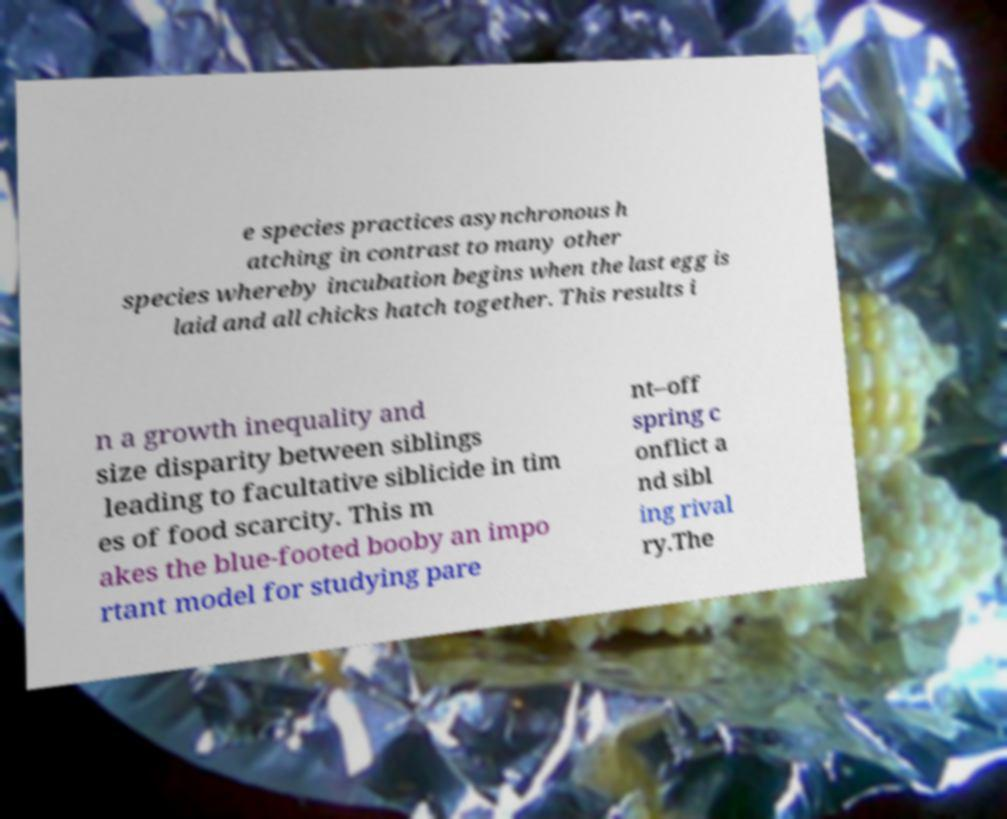I need the written content from this picture converted into text. Can you do that? e species practices asynchronous h atching in contrast to many other species whereby incubation begins when the last egg is laid and all chicks hatch together. This results i n a growth inequality and size disparity between siblings leading to facultative siblicide in tim es of food scarcity. This m akes the blue-footed booby an impo rtant model for studying pare nt–off spring c onflict a nd sibl ing rival ry.The 